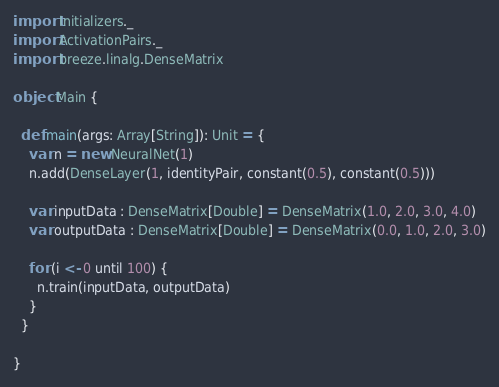Convert code to text. <code><loc_0><loc_0><loc_500><loc_500><_Scala_>import Initializers._
import ActivationPairs._
import breeze.linalg.DenseMatrix

object Main {

  def main(args: Array[String]): Unit = {
    var n = new NeuralNet(1)
    n.add(DenseLayer(1, identityPair, constant(0.5), constant(0.5)))

    var inputData : DenseMatrix[Double] = DenseMatrix(1.0, 2.0, 3.0, 4.0)
    var outputData : DenseMatrix[Double] = DenseMatrix(0.0, 1.0, 2.0, 3.0)

    for (i <- 0 until 100) {
      n.train(inputData, outputData)
    }
  }

}
</code> 